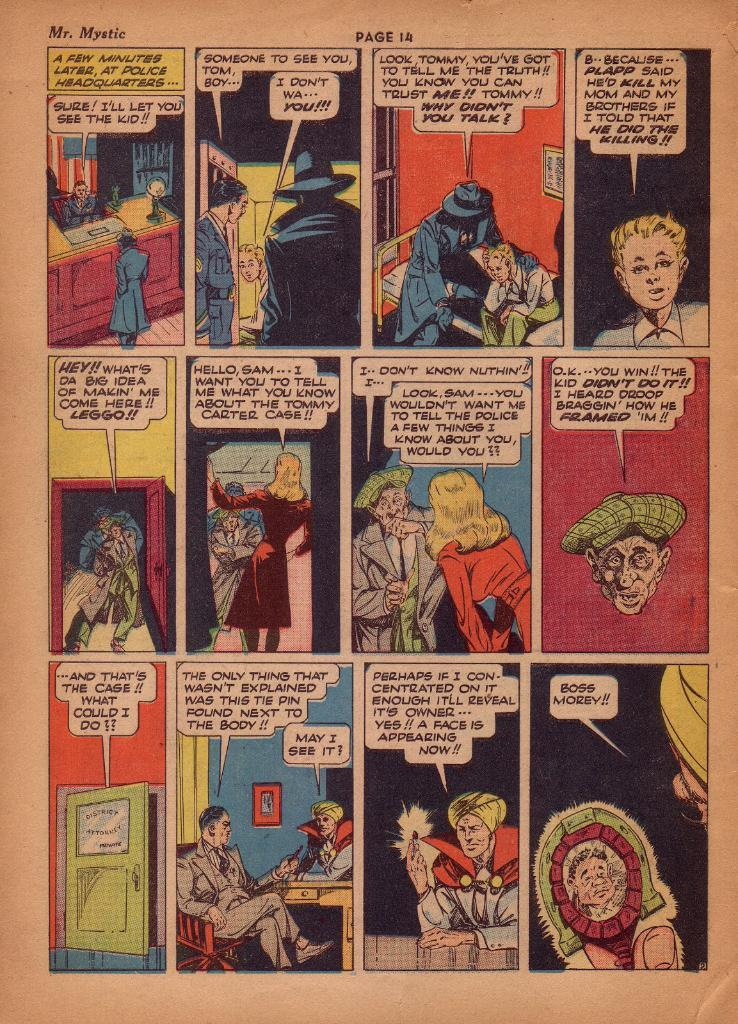<image>
Give a short and clear explanation of the subsequent image. a comic page for mr. mystic which is page 14 